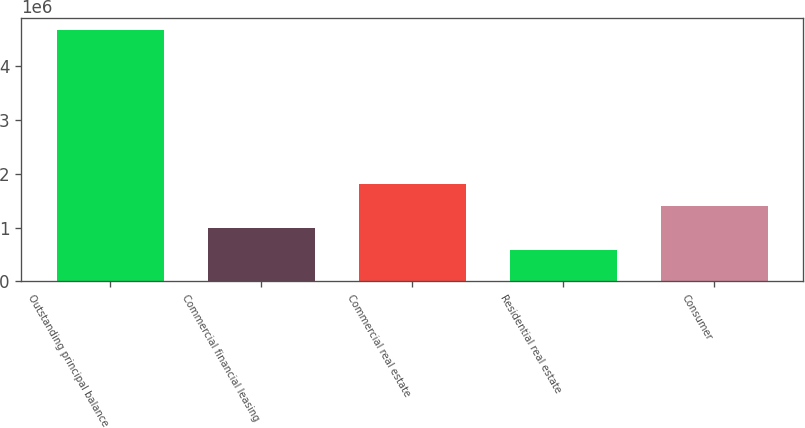Convert chart. <chart><loc_0><loc_0><loc_500><loc_500><bar_chart><fcel>Outstanding principal balance<fcel>Commercial financial leasing<fcel>Commercial real estate<fcel>Residential real estate<fcel>Consumer<nl><fcel>4.65681e+06<fcel>984507<fcel>1.80057e+06<fcel>576473<fcel>1.39254e+06<nl></chart> 